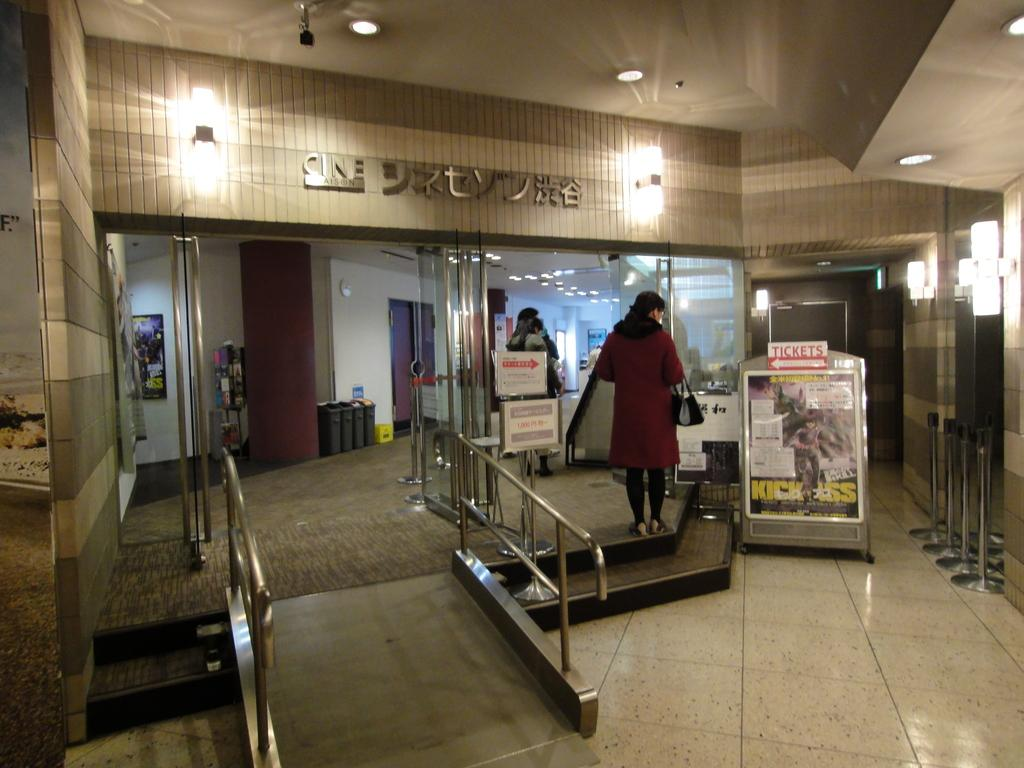What type of objects can be seen in the image made of glass? There are glass objects in the image. What other items can be seen in the image besides the glass objects? There are rods, stairs, banners, a wall, doors, people, and lights visible in the image. Can you describe the floor in the image? The floor is visible in the image. What architectural feature is present in the image that allows for movement between different levels? There are stairs in the image. What is visible at the top of the image? The ceiling is visible at the top of the image. How much payment is required to enter the room in the image? There is no indication of payment or an entrance fee in the image. What type of cord is being used to hang the holiday decorations in the image? There are no holiday decorations or cords present in the image. 